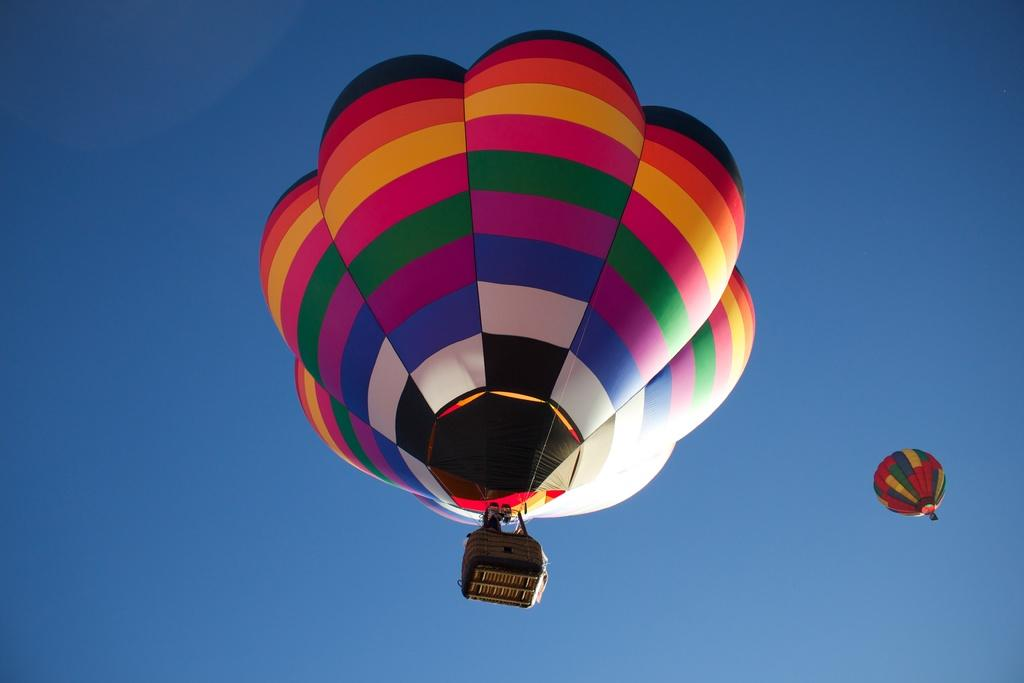What can be seen in the sky in the image? There are two parachutes in the sky. Who or what is attached to the parachutes? There are people in the parachutes. Where is the crate of musical instruments stored in the image? There is no crate of musical instruments present in the image. What type of shelf can be seen holding books in the image? There is no shelf or books visible in the image. 